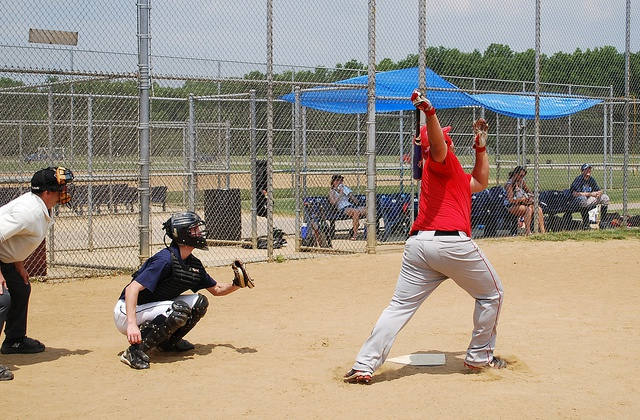Describe the objects in this image and their specific colors. I can see people in darkgray, lightgray, gray, and red tones, people in darkgray, black, gray, tan, and lightgray tones, people in darkgray, black, white, and gray tones, people in darkgray, gray, and black tones, and people in darkgray, brown, gray, maroon, and black tones in this image. 